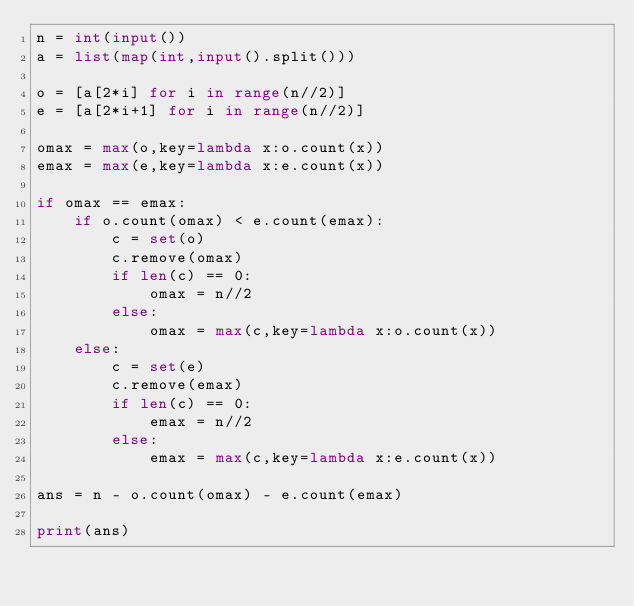<code> <loc_0><loc_0><loc_500><loc_500><_Python_>n = int(input())
a = list(map(int,input().split()))

o = [a[2*i] for i in range(n//2)]
e = [a[2*i+1] for i in range(n//2)]

omax = max(o,key=lambda x:o.count(x))
emax = max(e,key=lambda x:e.count(x))

if omax == emax:
    if o.count(omax) < e.count(emax):
        c = set(o)
        c.remove(omax)
        if len(c) == 0:
            omax = n//2
        else:
            omax = max(c,key=lambda x:o.count(x))
    else:
        c = set(e)
        c.remove(emax)
        if len(c) == 0:
            emax = n//2
        else:
            emax = max(c,key=lambda x:e.count(x))

ans = n - o.count(omax) - e.count(emax)

print(ans)</code> 